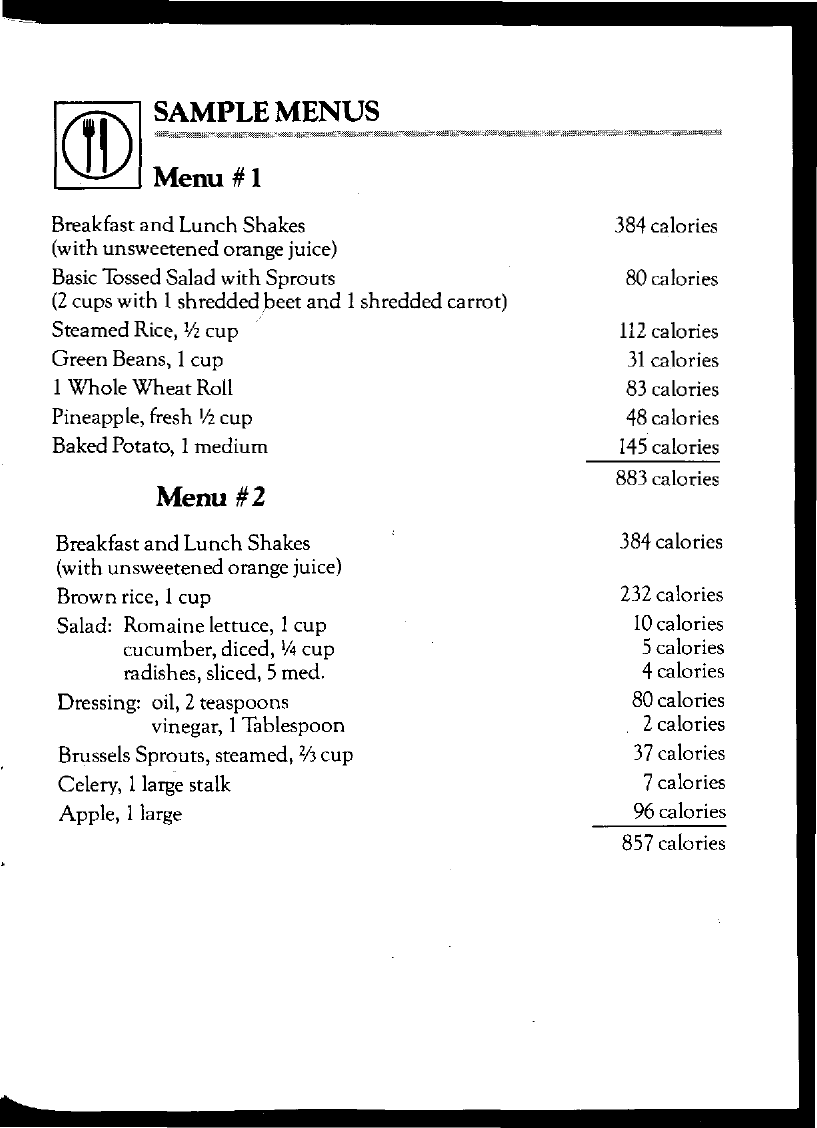What is the document title?
Offer a terse response. SAMPLE MENUS. How many calories does 1 large apple contain?
Offer a terse response. 96 calories. What is the total calories of Menu #1?
Provide a succinct answer. 883 calories. 